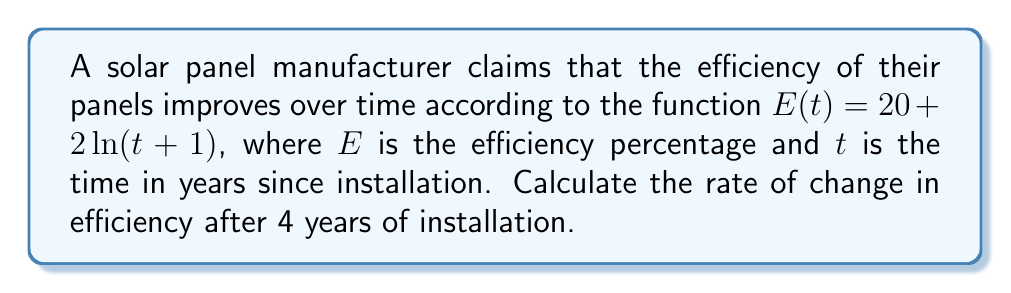Teach me how to tackle this problem. To find the rate of change in efficiency after 4 years, we need to calculate the derivative of the given function $E(t)$ and evaluate it at $t=4$.

Step 1: Identify the function
$E(t) = 20 + 2\ln(t+1)$

Step 2: Calculate the derivative
Using the chain rule:
$$\frac{dE}{dt} = 0 + 2 \cdot \frac{d}{dt}[\ln(t+1)]$$
$$\frac{dE}{dt} = 2 \cdot \frac{1}{t+1} \cdot \frac{d}{dt}[t+1]$$
$$\frac{dE}{dt} = 2 \cdot \frac{1}{t+1} \cdot 1$$
$$\frac{dE}{dt} = \frac{2}{t+1}$$

Step 3: Evaluate the derivative at t = 4
$$\frac{dE}{dt}\bigg|_{t=4} = \frac{2}{4+1} = \frac{2}{5} = 0.4$$

Therefore, the rate of change in efficiency after 4 years is 0.4% per year.
Answer: 0.4% per year 